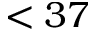<formula> <loc_0><loc_0><loc_500><loc_500>< 3 7</formula> 